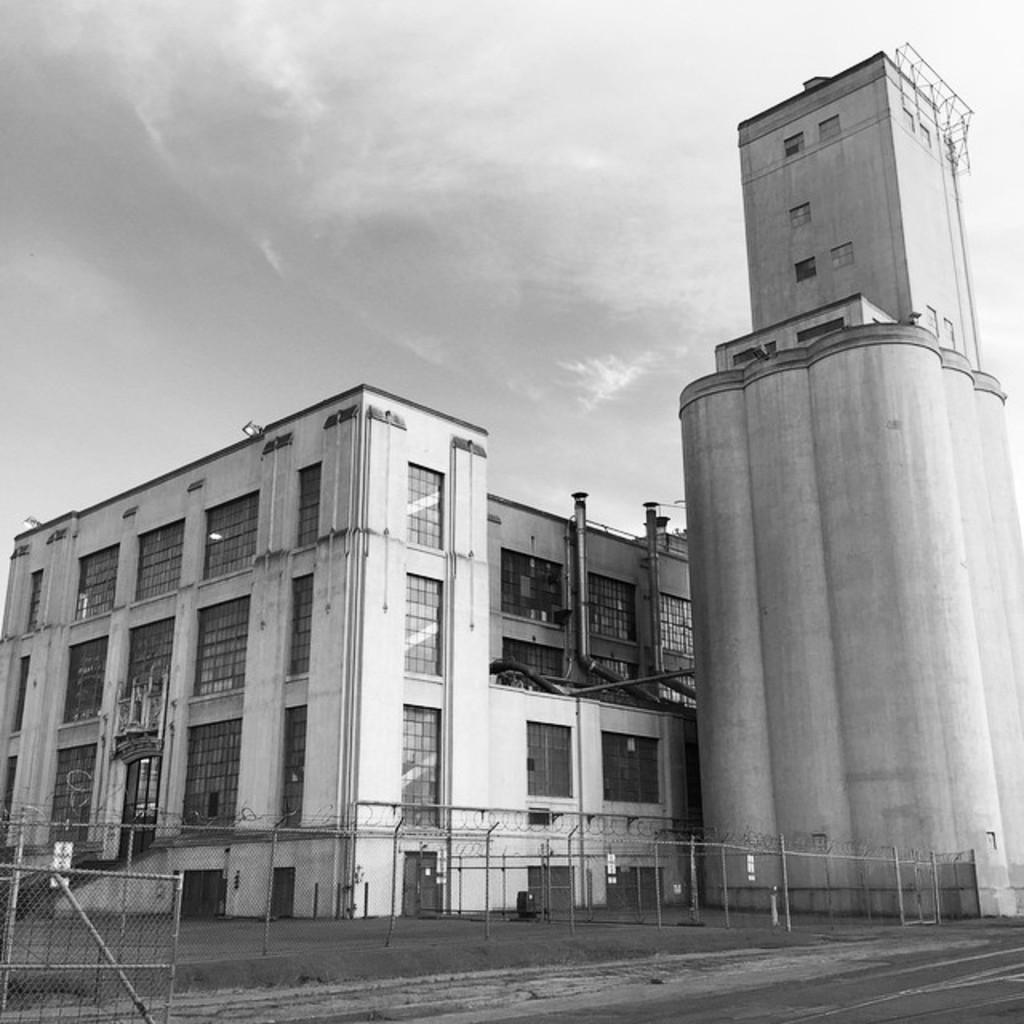What type of surface can be seen in the image? There is ground visible in the image. What type of structure is present in the image? There is metal fencing in the image. What kind of architecture is depicted in the image? There are huge buildings in the image. Are there any connections between the buildings and other structures? Yes, there are pipes connected to the buildings. What can be seen in the background of the image? The sky is visible in the background of the image. What type of bait is used to catch fish in the image? There is no mention of fish or fishing in the image, so it is not possible to determine what type of bait might be used. 